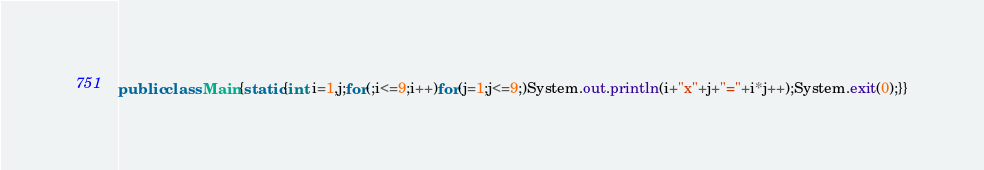Convert code to text. <code><loc_0><loc_0><loc_500><loc_500><_Java_>public class Main{static{int i=1,j;for(;i<=9;i++)for(j=1;j<=9;)System.out.println(i+"x"+j+"="+i*j++);System.exit(0);}}</code> 